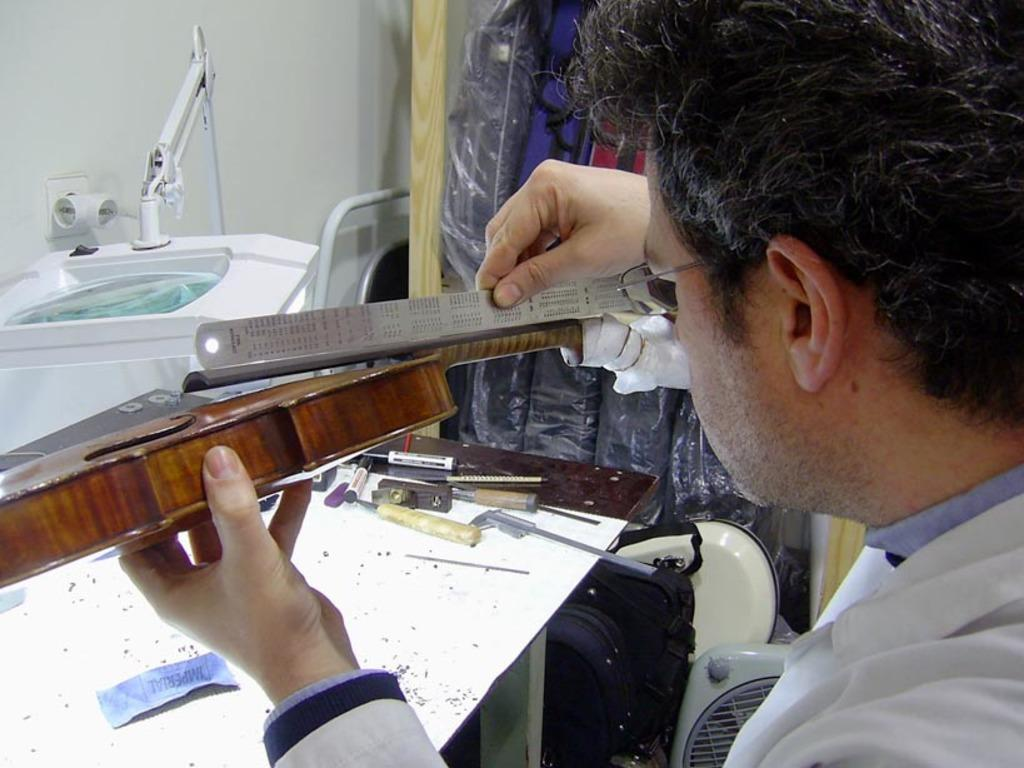What is the person in the image doing? The person is holding a scale in one hand and an object in the other hand. What can be seen in the background of the image? There are tools, markers, a table, walls, and a machine visible in the background of the image. What type of paste is being used on the person's face in the image? There is no paste or face visible in the image; it only shows a person holding a scale and an object, along with various items in the background. 